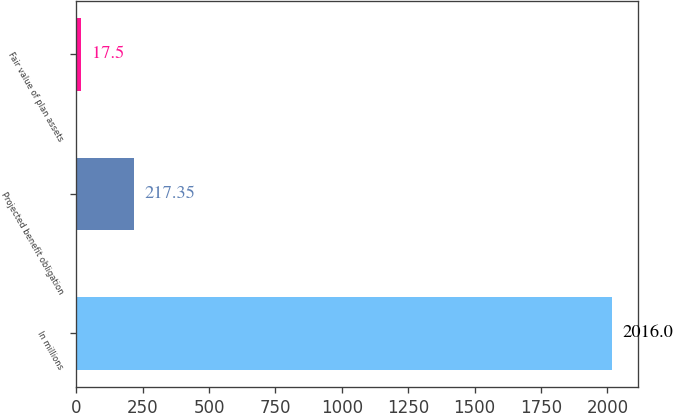<chart> <loc_0><loc_0><loc_500><loc_500><bar_chart><fcel>In millions<fcel>Projected benefit obligation<fcel>Fair value of plan assets<nl><fcel>2016<fcel>217.35<fcel>17.5<nl></chart> 